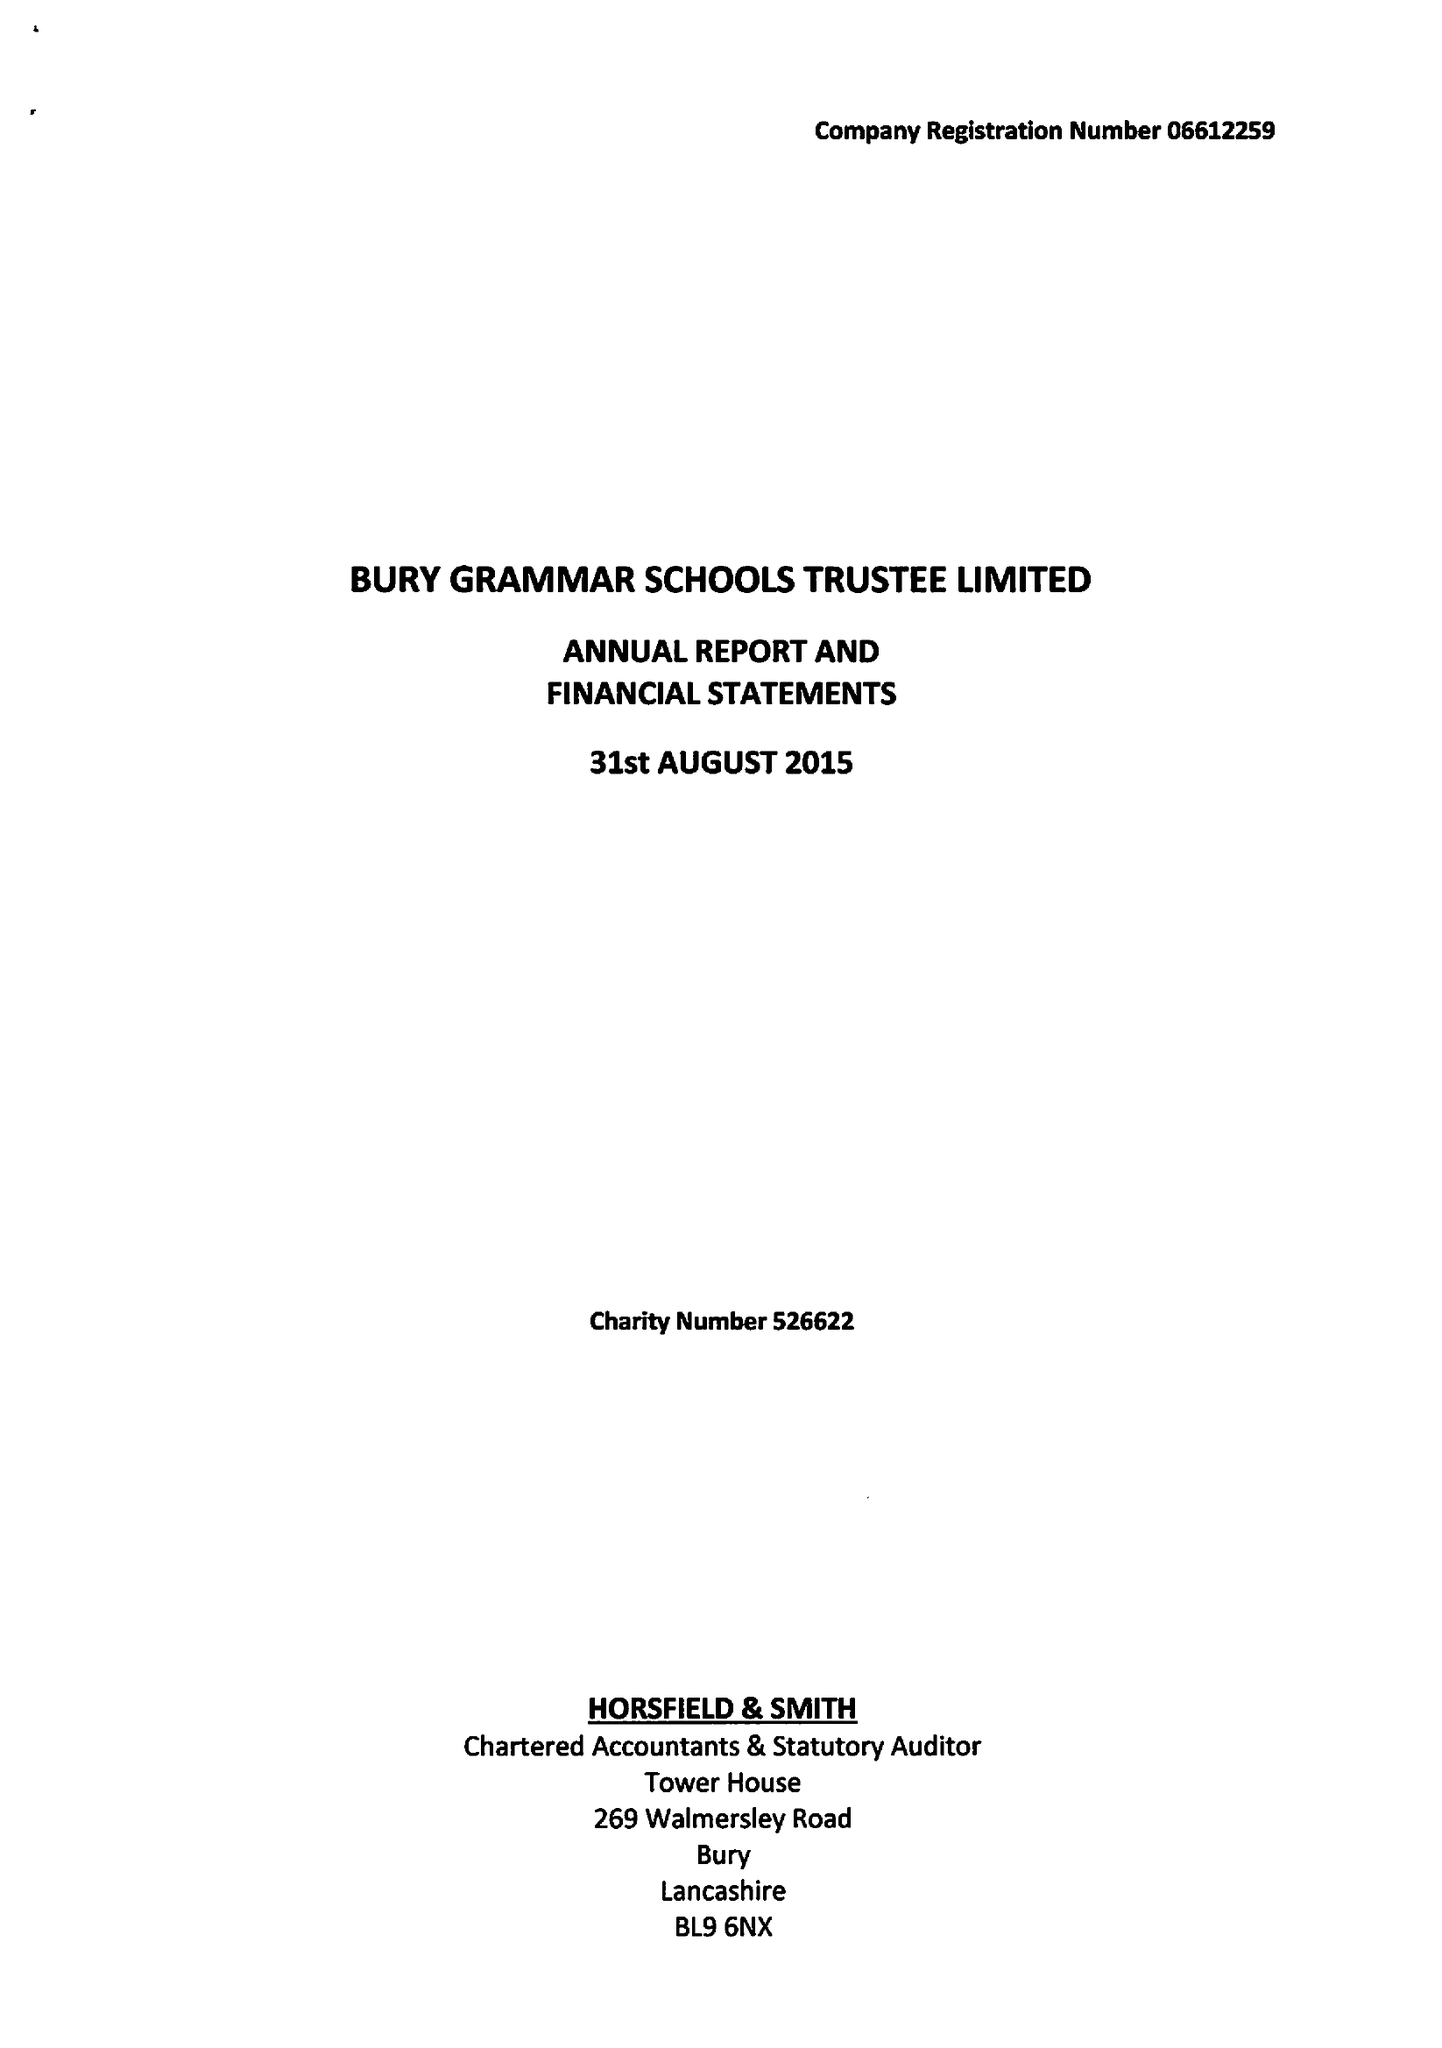What is the value for the income_annually_in_british_pounds?
Answer the question using a single word or phrase. 12938000.00 